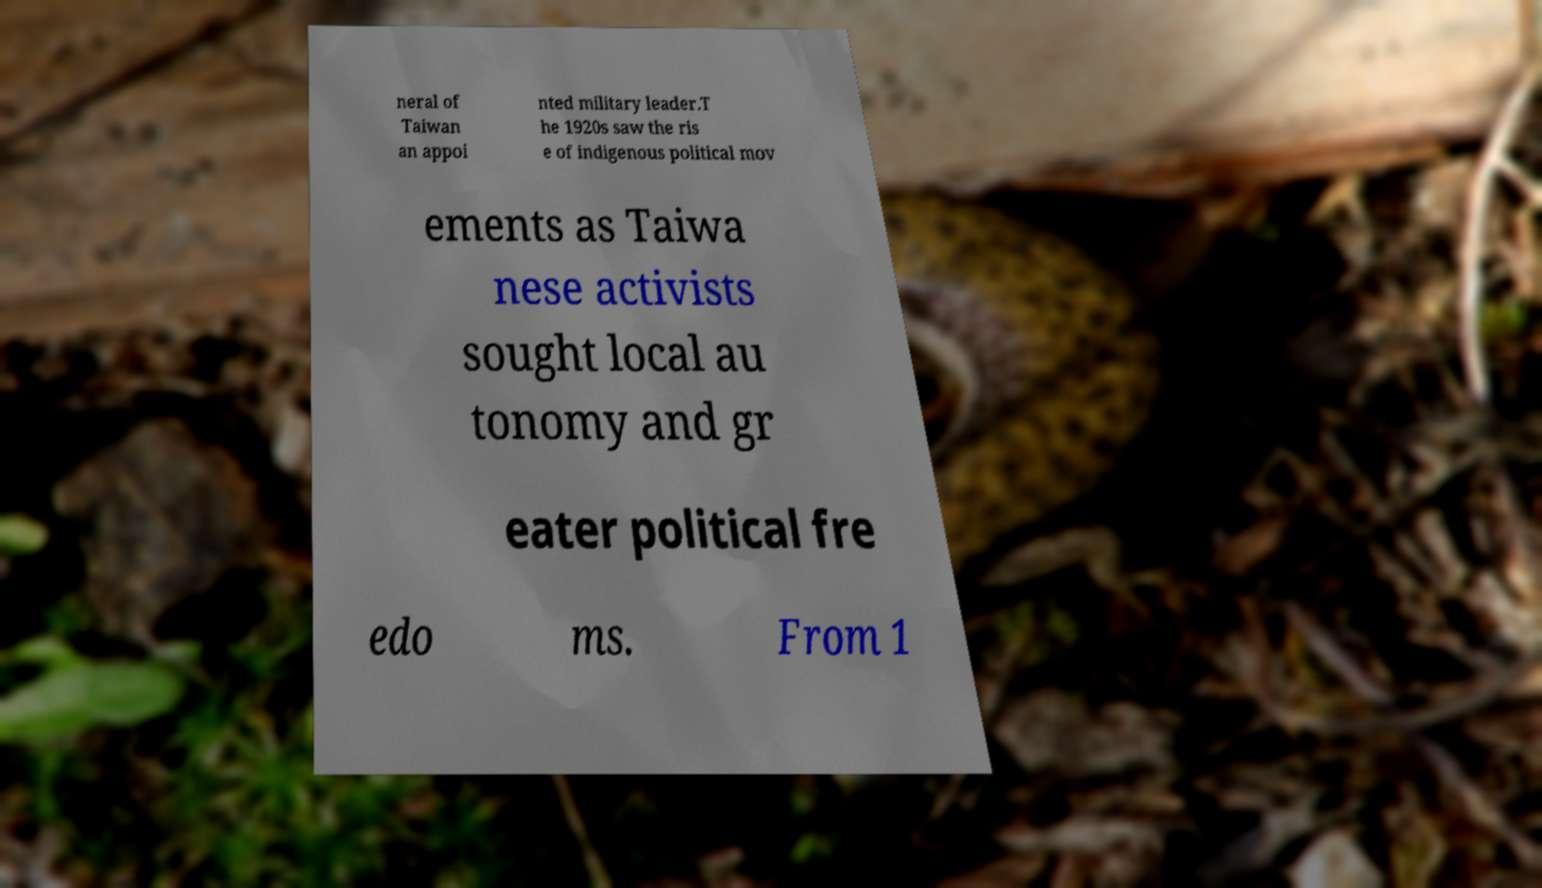Could you assist in decoding the text presented in this image and type it out clearly? neral of Taiwan an appoi nted military leader.T he 1920s saw the ris e of indigenous political mov ements as Taiwa nese activists sought local au tonomy and gr eater political fre edo ms. From 1 